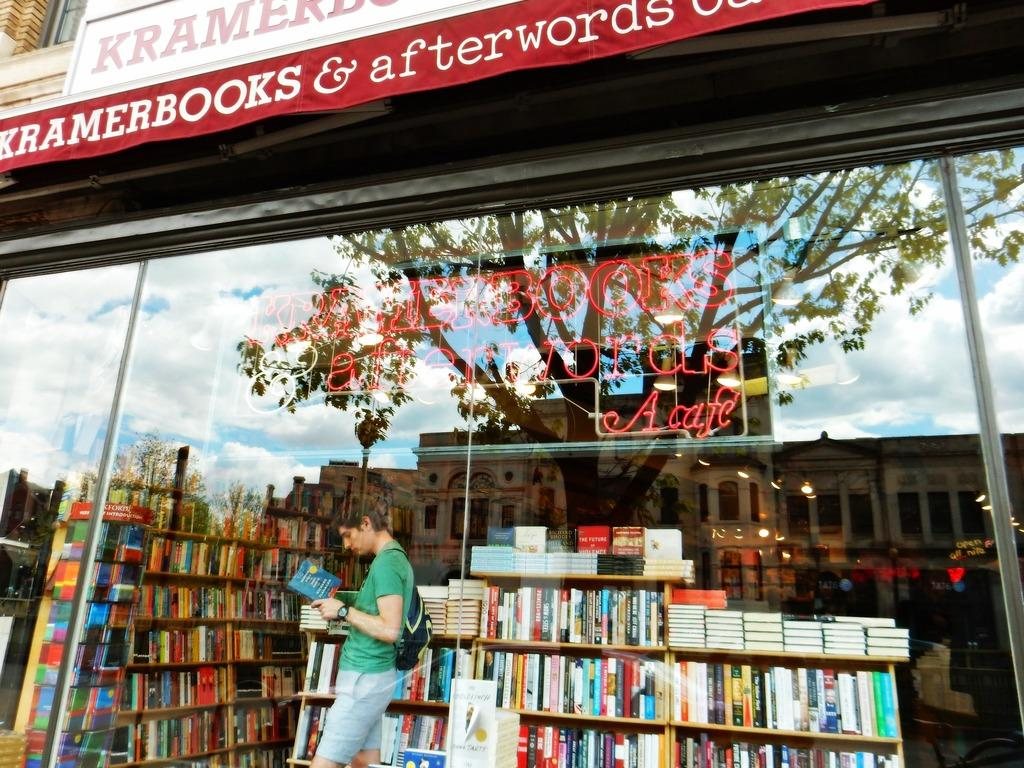<image>
Render a clear and concise summary of the photo. A sign for Kramer Books hangs above a store front filled with books. 